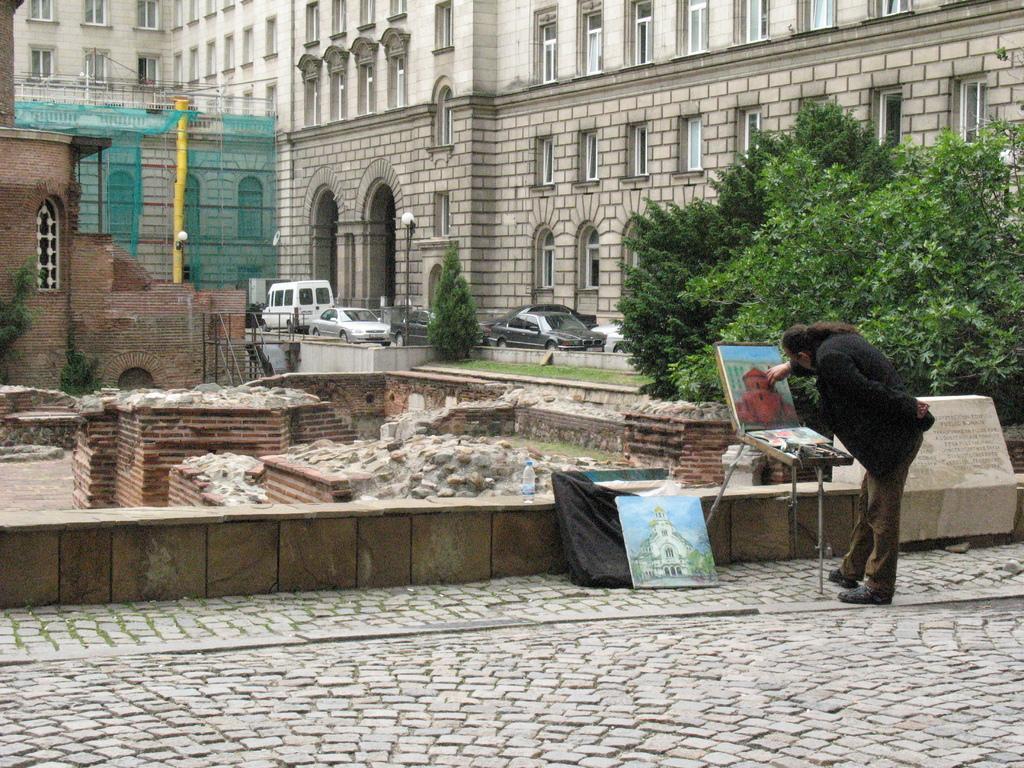Can you describe this image briefly? Here on the right we can see a man standing and painting on a board which is on the stand and beside to it there is a painted board and a cloth and a water bottle. In the background there are vehicles on the road,buildings,windows,poles,net,trees and grass. 